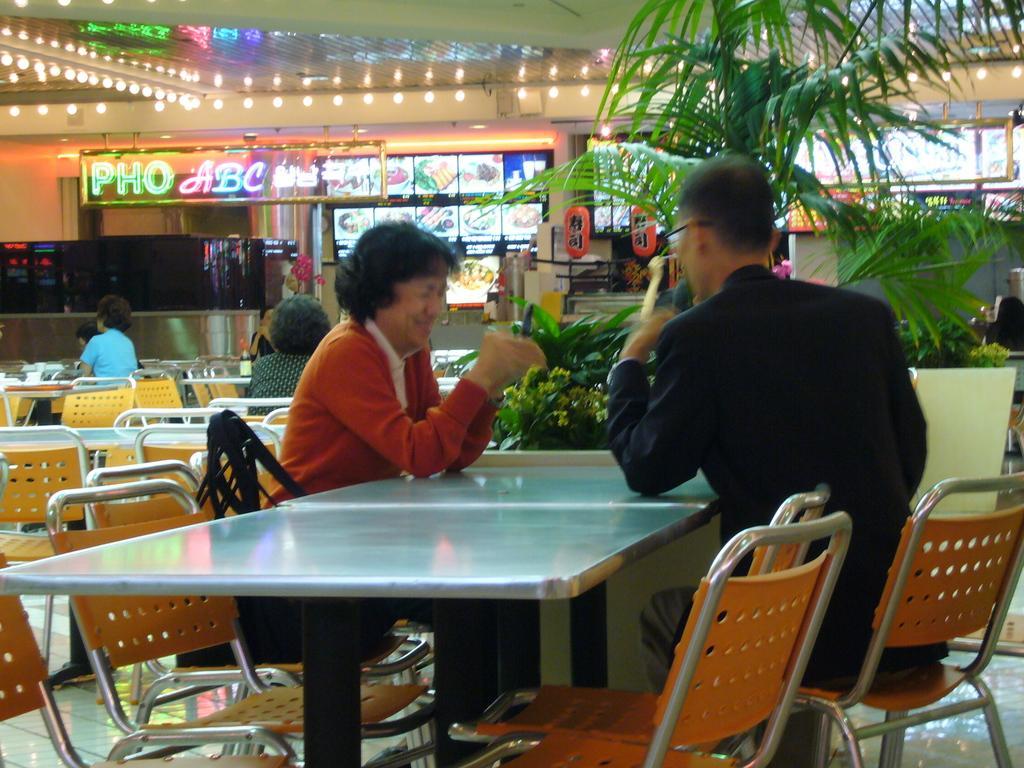Could you give a brief overview of what you see in this image? In this image there are group of persons sitting on the chair and at the background of the image there are plants and food item menu displaying on the screen. 